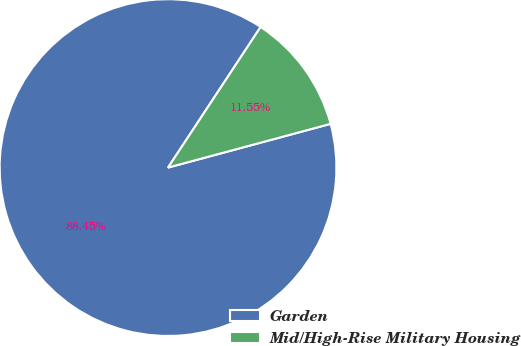Convert chart. <chart><loc_0><loc_0><loc_500><loc_500><pie_chart><fcel>Garden<fcel>Mid/High-Rise Military Housing<nl><fcel>88.45%<fcel>11.55%<nl></chart> 